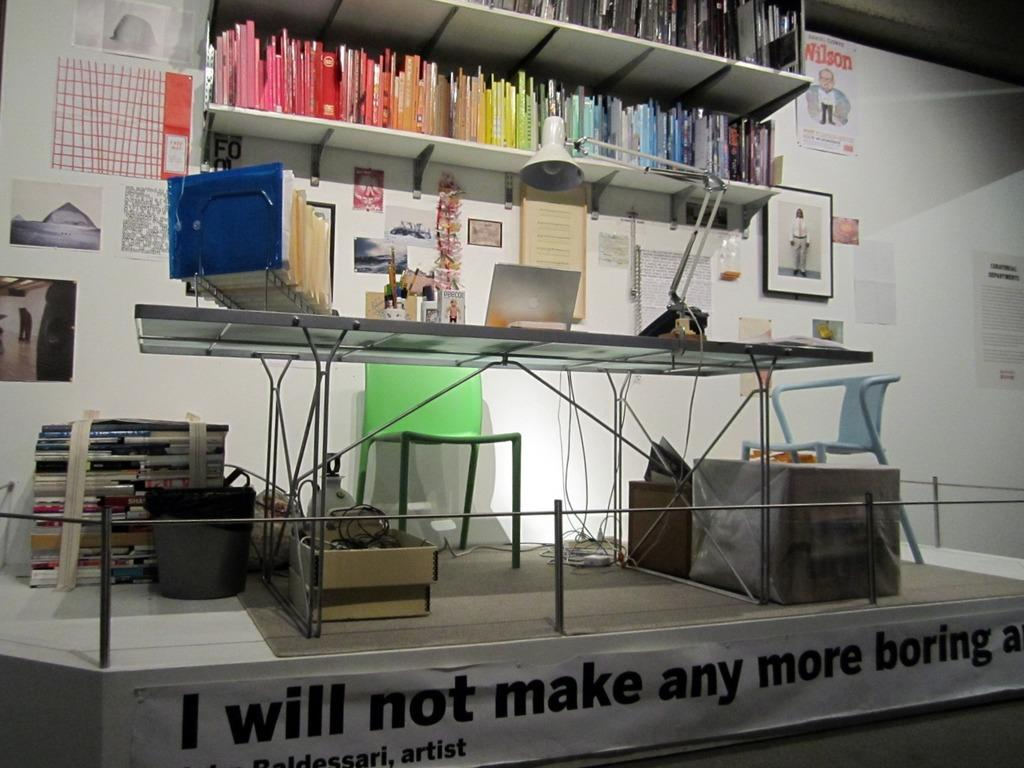<image>
Relay a brief, clear account of the picture shown. a banner that says i will not make any more boring 